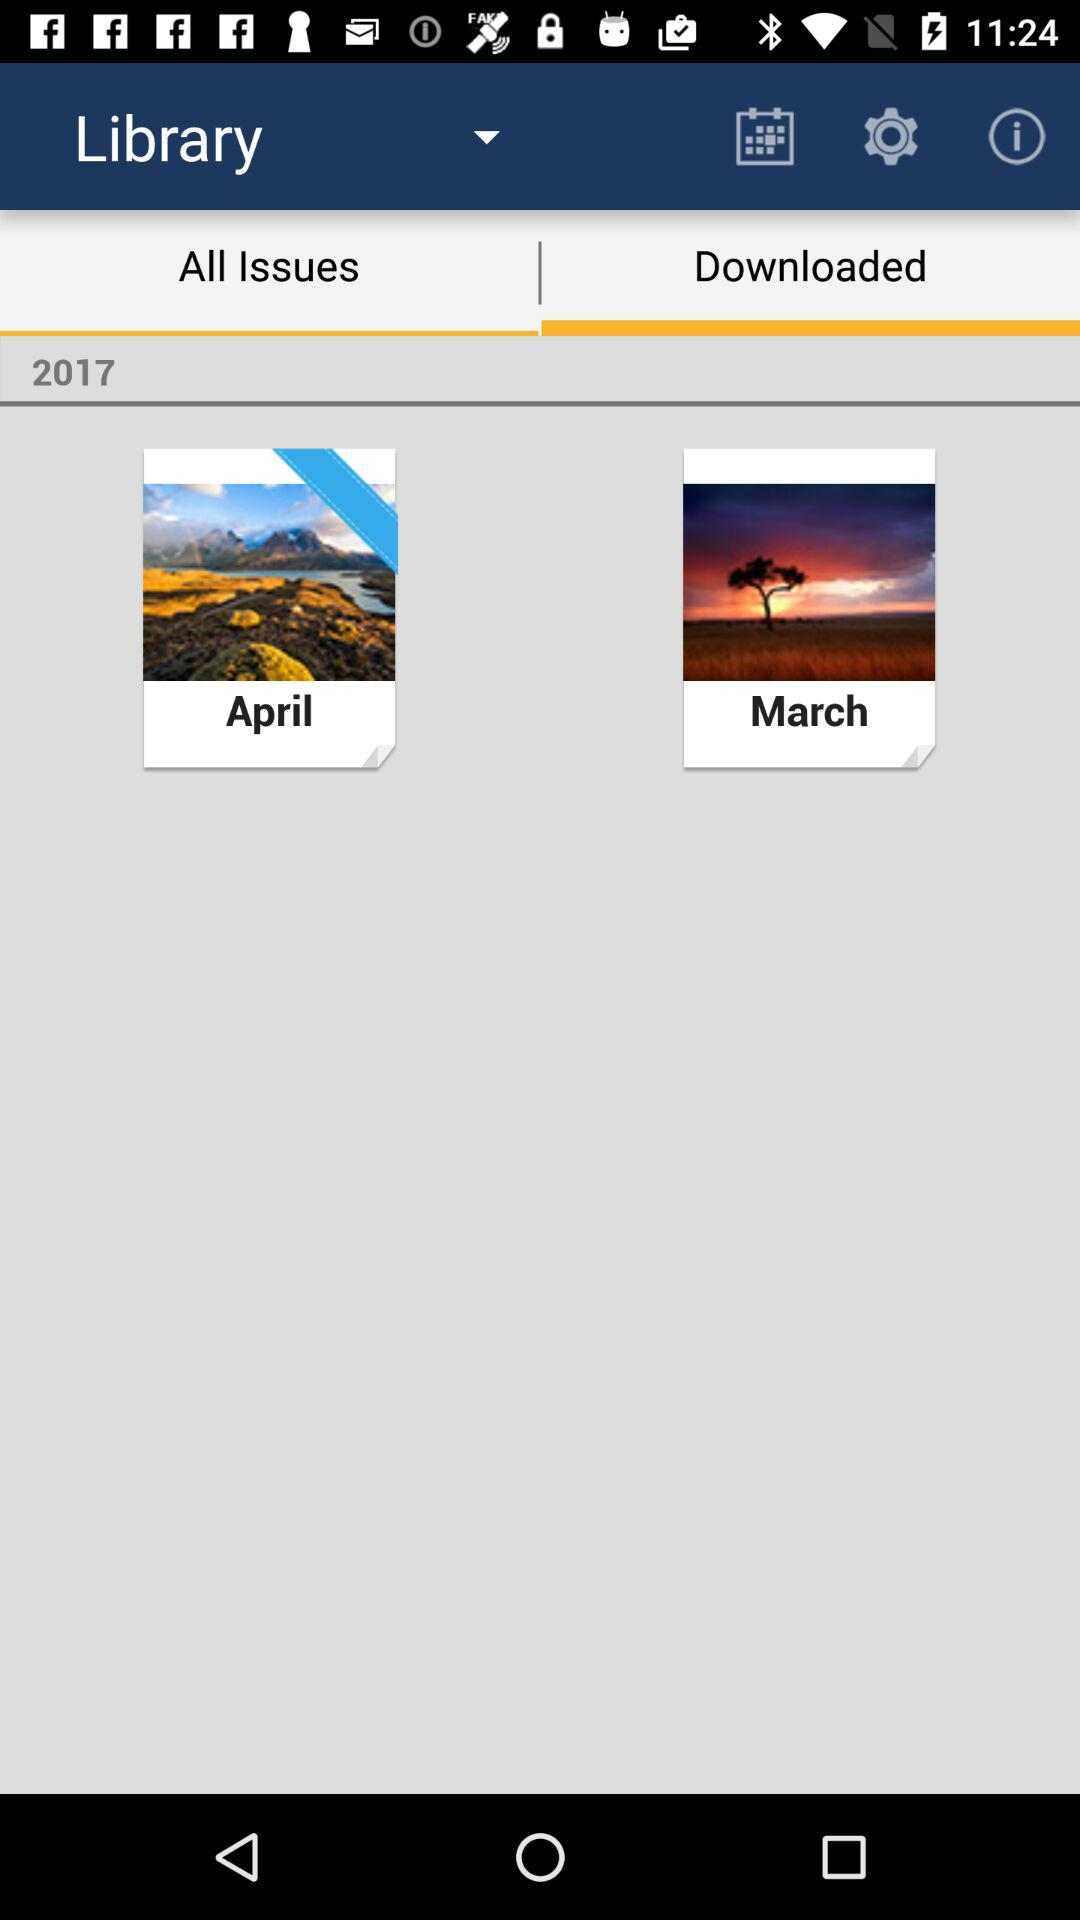Which tab is selected? The selected tab is "Downloaded". 